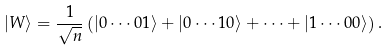<formula> <loc_0><loc_0><loc_500><loc_500>| W \rangle = \frac { 1 } { \sqrt { n } } \left ( | 0 \cdots 0 1 \rangle + | 0 \cdots 1 0 \rangle + \cdots + | 1 \cdots 0 0 \rangle \right ) .</formula> 